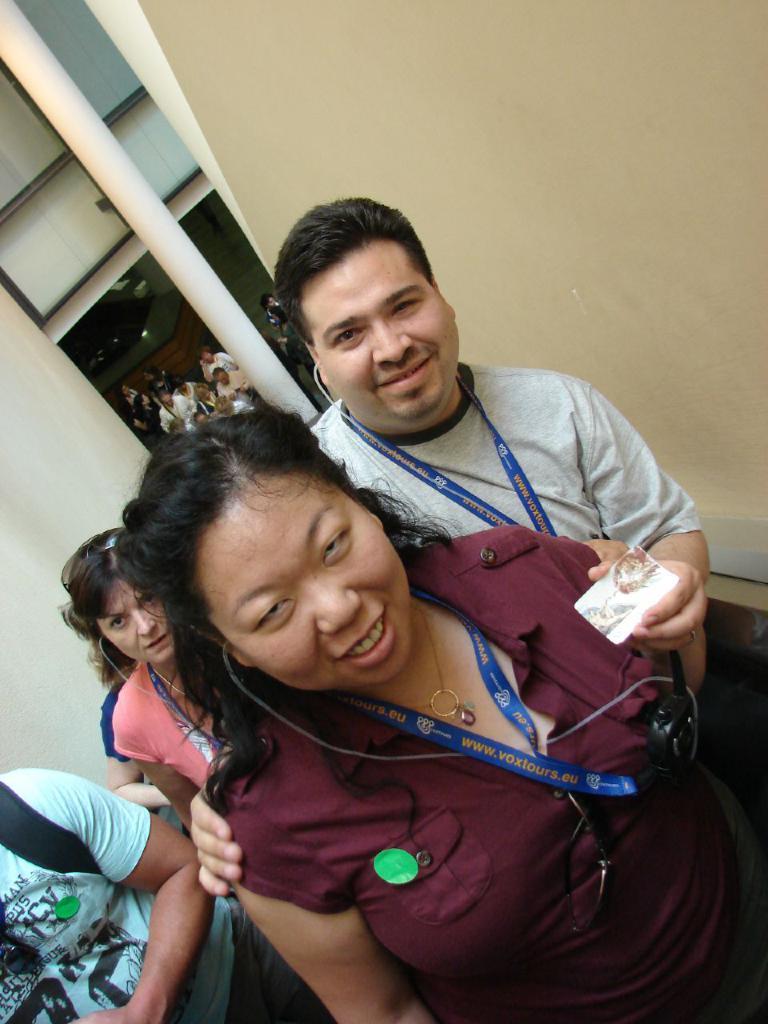How would you summarize this image in a sentence or two? In the foreground of the image there are people standing. In the background of the image there is a pillar. There is a wall. 